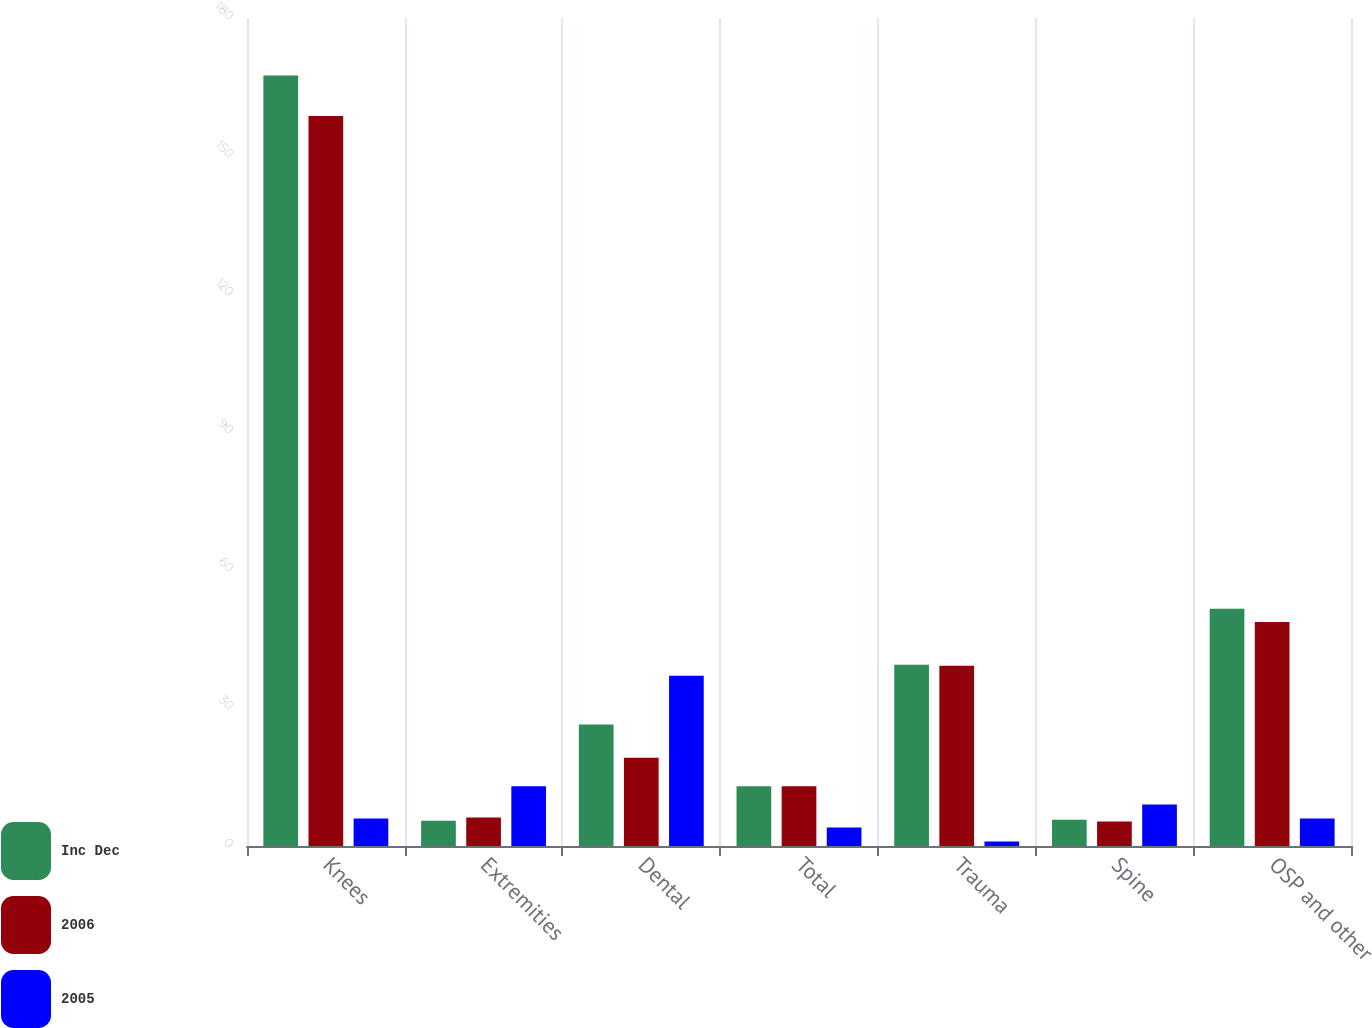Convert chart to OTSL. <chart><loc_0><loc_0><loc_500><loc_500><stacked_bar_chart><ecel><fcel>Knees<fcel>Extremities<fcel>Dental<fcel>Total<fcel>Trauma<fcel>Spine<fcel>OSP and other<nl><fcel>Inc Dec<fcel>167.5<fcel>5.5<fcel>26.4<fcel>13<fcel>39.4<fcel>5.7<fcel>51.6<nl><fcel>2006<fcel>158.7<fcel>6.2<fcel>19.2<fcel>13<fcel>39.2<fcel>5.3<fcel>48.7<nl><fcel>2005<fcel>6<fcel>13<fcel>37<fcel>4<fcel>1<fcel>9<fcel>6<nl></chart> 